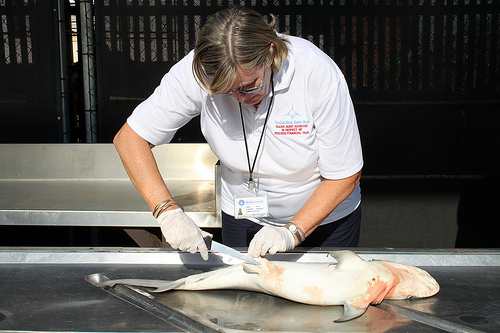<image>
Can you confirm if the woman is in front of the fish? Yes. The woman is positioned in front of the fish, appearing closer to the camera viewpoint. 